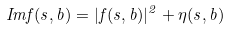Convert formula to latex. <formula><loc_0><loc_0><loc_500><loc_500>I m f ( s , b ) = | f ( s , b ) | ^ { 2 } + \eta ( s , b )</formula> 